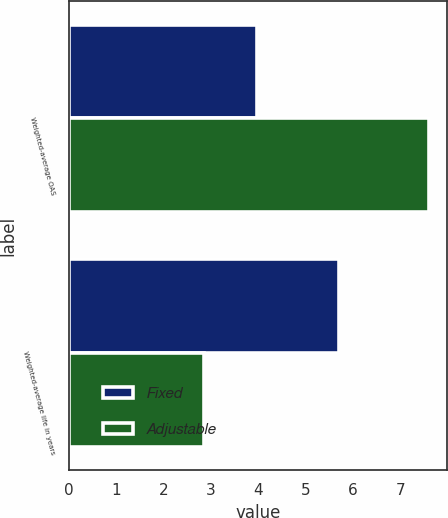<chart> <loc_0><loc_0><loc_500><loc_500><stacked_bar_chart><ecel><fcel>Weighted-average OAS<fcel>Weighted-average life in years<nl><fcel>Fixed<fcel>3.97<fcel>5.7<nl><fcel>Adjustable<fcel>7.61<fcel>2.86<nl></chart> 